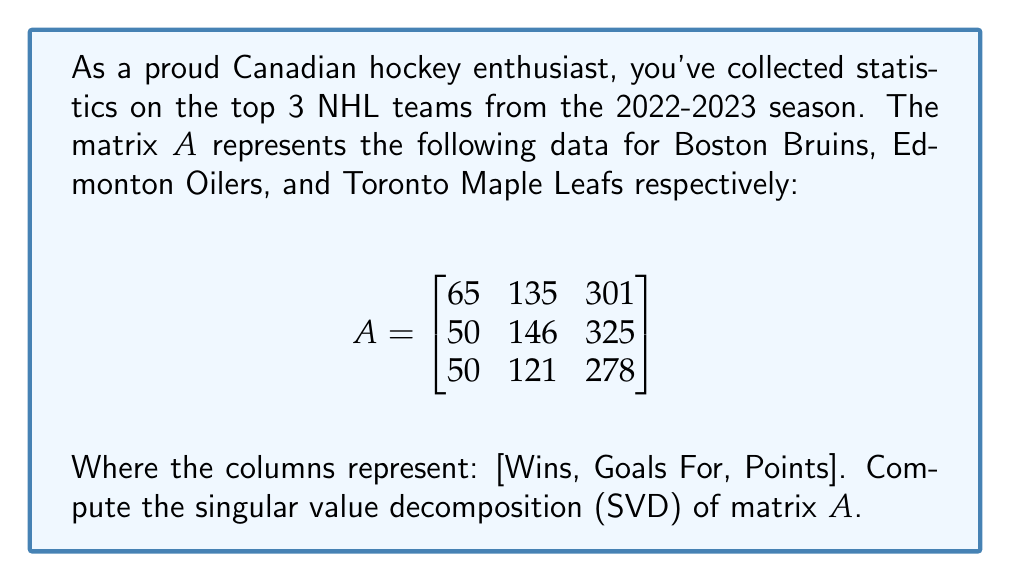Could you help me with this problem? To compute the singular value decomposition of matrix $A$, we need to find matrices $U$, $\Sigma$, and $V^T$ such that $A = U\Sigma V^T$.

Step 1: Calculate $A^TA$
$$A^TA = \begin{bmatrix}
65 & 50 & 50 \\
135 & 146 & 121 \\
301 & 325 & 278
\end{bmatrix} \begin{bmatrix}
65 & 135 & 301 \\
50 & 146 & 325 \\
50 & 121 & 278
\end{bmatrix} = \begin{bmatrix}
10450 & 25525 & 57415 \\
25525 & 68722 & 153121 \\
57415 & 153121 & 341930
\end{bmatrix}$$

Step 2: Find eigenvalues of $A^TA$
The characteristic equation is:
$\det(A^TA - \lambda I) = 0$

Solving this equation gives us the eigenvalues:
$\lambda_1 \approx 420693.8$
$\lambda_2 \approx 407.9$
$\lambda_3 \approx 0.3$

Step 3: Calculate singular values
The singular values are the square roots of the eigenvalues:
$\sigma_1 \approx 648.6$
$\sigma_2 \approx 20.2$
$\sigma_3 \approx 0.5$

Step 4: Find eigenvectors of $A^TA$
These eigenvectors form the columns of $V$. After normalization:
$$V \approx \begin{bmatrix}
0.1679 & -0.7071 & 0.6868 \\
0.3942 & 0.7071 & 0.5890 \\
0.9037 & 0 & -0.4282
\end{bmatrix}$$

Step 5: Calculate $U$
$U$ can be calculated using $U = AV\Sigma^{-1}$. After normalization:
$$U \approx \begin{bmatrix}
0.5774 & -0.5960 & 0.5578 \\
0.5774 & 0.7999 & 0.1636 \\
0.5774 & -0.0734 & -0.8133
\end{bmatrix}$$

Step 6: Construct $\Sigma$
$$\Sigma = \begin{bmatrix}
648.6 & 0 & 0 \\
0 & 20.2 & 0 \\
0 & 0 & 0.5
\end{bmatrix}$$

Therefore, the singular value decomposition of $A$ is $A = U\Sigma V^T$.
Answer: The singular value decomposition of matrix $A$ is:

$A = U\Sigma V^T$

Where:

$$U \approx \begin{bmatrix}
0.5774 & -0.5960 & 0.5578 \\
0.5774 & 0.7999 & 0.1636 \\
0.5774 & -0.0734 & -0.8133
\end{bmatrix}$$

$$\Sigma = \begin{bmatrix}
648.6 & 0 & 0 \\
0 & 20.2 & 0 \\
0 & 0 & 0.5
\end{bmatrix}$$

$$V^T \approx \begin{bmatrix}
0.1679 & 0.3942 & 0.9037 \\
-0.7071 & 0.7071 & 0 \\
0.6868 & 0.5890 & -0.4282
\end{bmatrix}$$ 